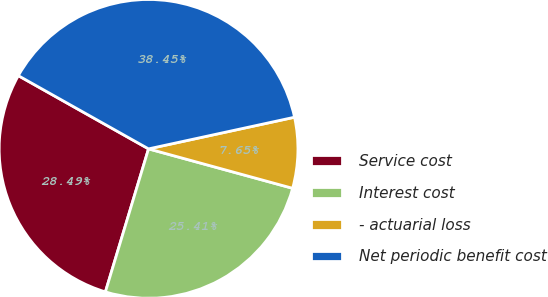<chart> <loc_0><loc_0><loc_500><loc_500><pie_chart><fcel>Service cost<fcel>Interest cost<fcel>- actuarial loss<fcel>Net periodic benefit cost<nl><fcel>28.49%<fcel>25.41%<fcel>7.65%<fcel>38.45%<nl></chart> 